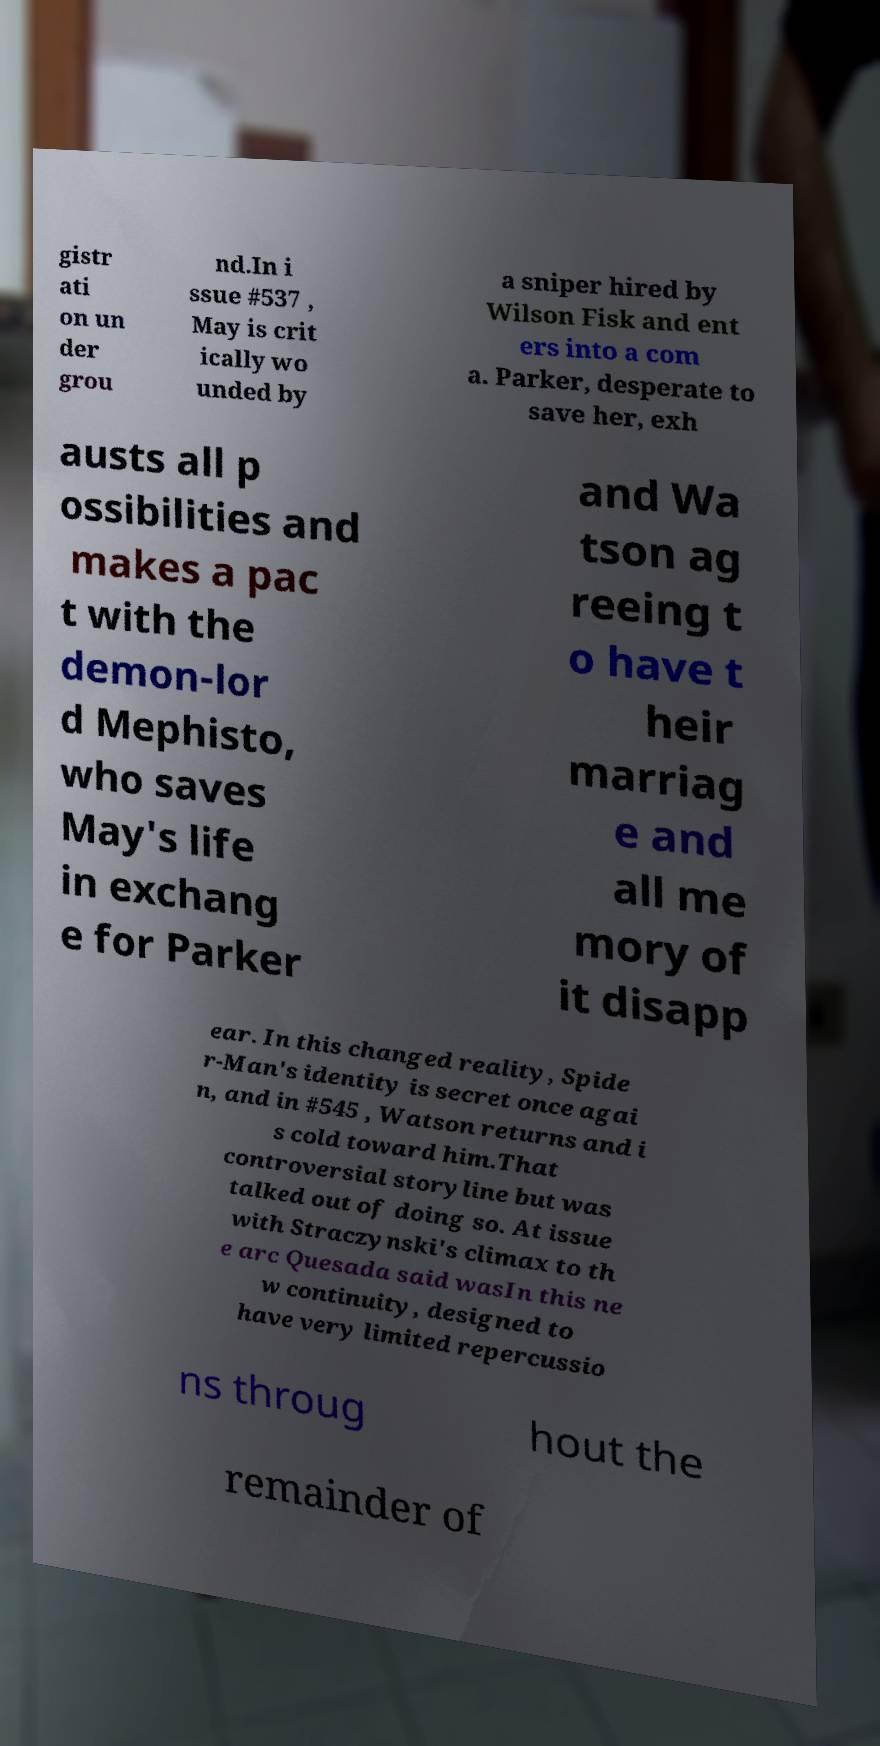Please read and relay the text visible in this image. What does it say? gistr ati on un der grou nd.In i ssue #537 , May is crit ically wo unded by a sniper hired by Wilson Fisk and ent ers into a com a. Parker, desperate to save her, exh austs all p ossibilities and makes a pac t with the demon-lor d Mephisto, who saves May's life in exchang e for Parker and Wa tson ag reeing t o have t heir marriag e and all me mory of it disapp ear. In this changed reality, Spide r-Man's identity is secret once agai n, and in #545 , Watson returns and i s cold toward him.That controversial storyline but was talked out of doing so. At issue with Straczynski's climax to th e arc Quesada said wasIn this ne w continuity, designed to have very limited repercussio ns throug hout the remainder of 